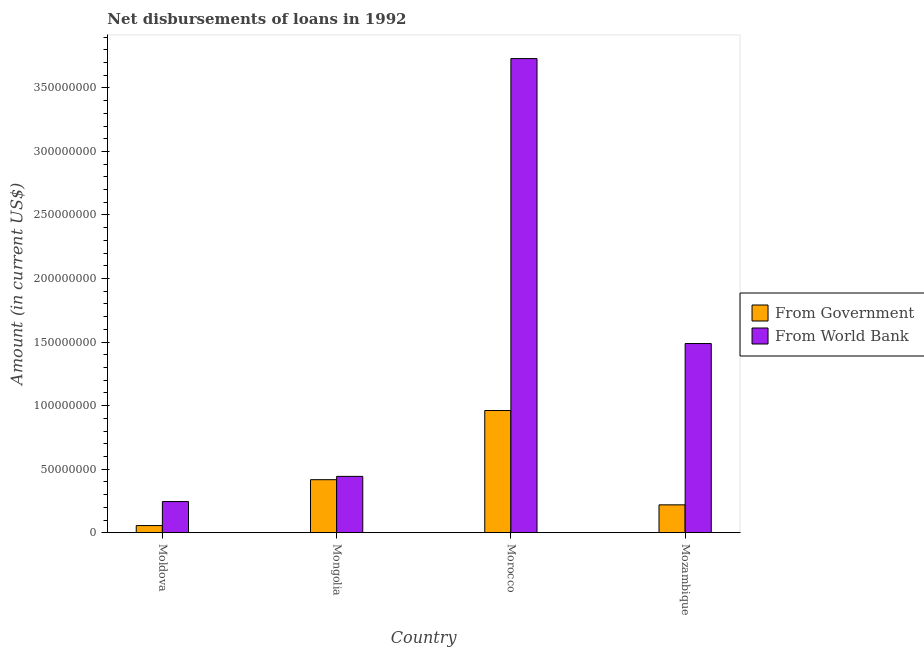How many different coloured bars are there?
Give a very brief answer. 2. Are the number of bars on each tick of the X-axis equal?
Your answer should be compact. Yes. How many bars are there on the 1st tick from the left?
Keep it short and to the point. 2. What is the label of the 2nd group of bars from the left?
Offer a terse response. Mongolia. What is the net disbursements of loan from government in Moldova?
Offer a very short reply. 5.62e+06. Across all countries, what is the maximum net disbursements of loan from government?
Provide a succinct answer. 9.61e+07. Across all countries, what is the minimum net disbursements of loan from world bank?
Make the answer very short. 2.45e+07. In which country was the net disbursements of loan from world bank maximum?
Provide a succinct answer. Morocco. In which country was the net disbursements of loan from world bank minimum?
Give a very brief answer. Moldova. What is the total net disbursements of loan from world bank in the graph?
Your response must be concise. 5.91e+08. What is the difference between the net disbursements of loan from world bank in Moldova and that in Mozambique?
Your response must be concise. -1.24e+08. What is the difference between the net disbursements of loan from government in Morocco and the net disbursements of loan from world bank in Mongolia?
Make the answer very short. 5.18e+07. What is the average net disbursements of loan from government per country?
Offer a terse response. 4.13e+07. What is the difference between the net disbursements of loan from world bank and net disbursements of loan from government in Mongolia?
Make the answer very short. 2.60e+06. What is the ratio of the net disbursements of loan from world bank in Mongolia to that in Mozambique?
Keep it short and to the point. 0.3. Is the net disbursements of loan from government in Moldova less than that in Mozambique?
Ensure brevity in your answer.  Yes. What is the difference between the highest and the second highest net disbursements of loan from world bank?
Offer a terse response. 2.24e+08. What is the difference between the highest and the lowest net disbursements of loan from world bank?
Provide a succinct answer. 3.49e+08. What does the 1st bar from the left in Morocco represents?
Ensure brevity in your answer.  From Government. What does the 1st bar from the right in Mongolia represents?
Offer a terse response. From World Bank. How many bars are there?
Provide a short and direct response. 8. How many countries are there in the graph?
Make the answer very short. 4. What is the difference between two consecutive major ticks on the Y-axis?
Ensure brevity in your answer.  5.00e+07. Are the values on the major ticks of Y-axis written in scientific E-notation?
Provide a succinct answer. No. Does the graph contain any zero values?
Your response must be concise. No. How many legend labels are there?
Make the answer very short. 2. What is the title of the graph?
Your answer should be compact. Net disbursements of loans in 1992. What is the label or title of the X-axis?
Your answer should be compact. Country. What is the Amount (in current US$) of From Government in Moldova?
Provide a succinct answer. 5.62e+06. What is the Amount (in current US$) of From World Bank in Moldova?
Keep it short and to the point. 2.45e+07. What is the Amount (in current US$) in From Government in Mongolia?
Offer a very short reply. 4.17e+07. What is the Amount (in current US$) of From World Bank in Mongolia?
Ensure brevity in your answer.  4.43e+07. What is the Amount (in current US$) in From Government in Morocco?
Keep it short and to the point. 9.61e+07. What is the Amount (in current US$) in From World Bank in Morocco?
Offer a very short reply. 3.73e+08. What is the Amount (in current US$) in From Government in Mozambique?
Your answer should be very brief. 2.19e+07. What is the Amount (in current US$) in From World Bank in Mozambique?
Ensure brevity in your answer.  1.49e+08. Across all countries, what is the maximum Amount (in current US$) of From Government?
Your response must be concise. 9.61e+07. Across all countries, what is the maximum Amount (in current US$) in From World Bank?
Make the answer very short. 3.73e+08. Across all countries, what is the minimum Amount (in current US$) of From Government?
Your answer should be compact. 5.62e+06. Across all countries, what is the minimum Amount (in current US$) in From World Bank?
Your response must be concise. 2.45e+07. What is the total Amount (in current US$) of From Government in the graph?
Ensure brevity in your answer.  1.65e+08. What is the total Amount (in current US$) in From World Bank in the graph?
Provide a succinct answer. 5.91e+08. What is the difference between the Amount (in current US$) of From Government in Moldova and that in Mongolia?
Provide a short and direct response. -3.61e+07. What is the difference between the Amount (in current US$) of From World Bank in Moldova and that in Mongolia?
Provide a short and direct response. -1.98e+07. What is the difference between the Amount (in current US$) of From Government in Moldova and that in Morocco?
Ensure brevity in your answer.  -9.05e+07. What is the difference between the Amount (in current US$) of From World Bank in Moldova and that in Morocco?
Offer a very short reply. -3.49e+08. What is the difference between the Amount (in current US$) of From Government in Moldova and that in Mozambique?
Your response must be concise. -1.63e+07. What is the difference between the Amount (in current US$) in From World Bank in Moldova and that in Mozambique?
Keep it short and to the point. -1.24e+08. What is the difference between the Amount (in current US$) of From Government in Mongolia and that in Morocco?
Your response must be concise. -5.44e+07. What is the difference between the Amount (in current US$) in From World Bank in Mongolia and that in Morocco?
Your response must be concise. -3.29e+08. What is the difference between the Amount (in current US$) in From Government in Mongolia and that in Mozambique?
Offer a very short reply. 1.98e+07. What is the difference between the Amount (in current US$) in From World Bank in Mongolia and that in Mozambique?
Offer a terse response. -1.05e+08. What is the difference between the Amount (in current US$) of From Government in Morocco and that in Mozambique?
Ensure brevity in your answer.  7.42e+07. What is the difference between the Amount (in current US$) of From World Bank in Morocco and that in Mozambique?
Provide a succinct answer. 2.24e+08. What is the difference between the Amount (in current US$) in From Government in Moldova and the Amount (in current US$) in From World Bank in Mongolia?
Give a very brief answer. -3.87e+07. What is the difference between the Amount (in current US$) of From Government in Moldova and the Amount (in current US$) of From World Bank in Morocco?
Offer a terse response. -3.67e+08. What is the difference between the Amount (in current US$) in From Government in Moldova and the Amount (in current US$) in From World Bank in Mozambique?
Ensure brevity in your answer.  -1.43e+08. What is the difference between the Amount (in current US$) of From Government in Mongolia and the Amount (in current US$) of From World Bank in Morocco?
Offer a very short reply. -3.31e+08. What is the difference between the Amount (in current US$) in From Government in Mongolia and the Amount (in current US$) in From World Bank in Mozambique?
Give a very brief answer. -1.07e+08. What is the difference between the Amount (in current US$) of From Government in Morocco and the Amount (in current US$) of From World Bank in Mozambique?
Provide a succinct answer. -5.27e+07. What is the average Amount (in current US$) in From Government per country?
Provide a succinct answer. 4.13e+07. What is the average Amount (in current US$) of From World Bank per country?
Make the answer very short. 1.48e+08. What is the difference between the Amount (in current US$) in From Government and Amount (in current US$) in From World Bank in Moldova?
Your response must be concise. -1.89e+07. What is the difference between the Amount (in current US$) in From Government and Amount (in current US$) in From World Bank in Mongolia?
Offer a terse response. -2.60e+06. What is the difference between the Amount (in current US$) of From Government and Amount (in current US$) of From World Bank in Morocco?
Your answer should be compact. -2.77e+08. What is the difference between the Amount (in current US$) in From Government and Amount (in current US$) in From World Bank in Mozambique?
Keep it short and to the point. -1.27e+08. What is the ratio of the Amount (in current US$) in From Government in Moldova to that in Mongolia?
Ensure brevity in your answer.  0.13. What is the ratio of the Amount (in current US$) in From World Bank in Moldova to that in Mongolia?
Offer a very short reply. 0.55. What is the ratio of the Amount (in current US$) of From Government in Moldova to that in Morocco?
Offer a terse response. 0.06. What is the ratio of the Amount (in current US$) of From World Bank in Moldova to that in Morocco?
Keep it short and to the point. 0.07. What is the ratio of the Amount (in current US$) in From Government in Moldova to that in Mozambique?
Your response must be concise. 0.26. What is the ratio of the Amount (in current US$) in From World Bank in Moldova to that in Mozambique?
Make the answer very short. 0.16. What is the ratio of the Amount (in current US$) in From Government in Mongolia to that in Morocco?
Provide a short and direct response. 0.43. What is the ratio of the Amount (in current US$) in From World Bank in Mongolia to that in Morocco?
Keep it short and to the point. 0.12. What is the ratio of the Amount (in current US$) of From Government in Mongolia to that in Mozambique?
Make the answer very short. 1.9. What is the ratio of the Amount (in current US$) in From World Bank in Mongolia to that in Mozambique?
Your response must be concise. 0.3. What is the ratio of the Amount (in current US$) of From Government in Morocco to that in Mozambique?
Keep it short and to the point. 4.39. What is the ratio of the Amount (in current US$) in From World Bank in Morocco to that in Mozambique?
Offer a very short reply. 2.51. What is the difference between the highest and the second highest Amount (in current US$) in From Government?
Make the answer very short. 5.44e+07. What is the difference between the highest and the second highest Amount (in current US$) in From World Bank?
Provide a short and direct response. 2.24e+08. What is the difference between the highest and the lowest Amount (in current US$) of From Government?
Make the answer very short. 9.05e+07. What is the difference between the highest and the lowest Amount (in current US$) of From World Bank?
Your answer should be very brief. 3.49e+08. 